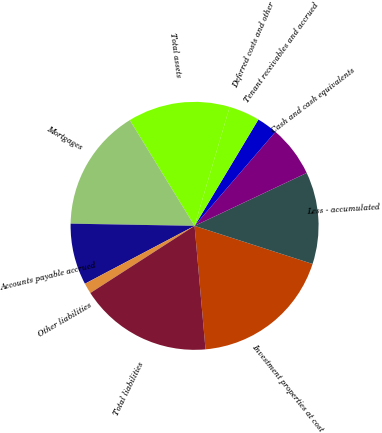<chart> <loc_0><loc_0><loc_500><loc_500><pie_chart><fcel>Investment properties at cost<fcel>Less - accumulated<fcel>Cash and cash equivalents<fcel>Tenant receivables and accrued<fcel>Deferred costs and other<fcel>Total assets<fcel>Mortgages<fcel>Accounts payable accrued<fcel>Other liabilities<fcel>Total liabilities<nl><fcel>18.62%<fcel>11.99%<fcel>6.68%<fcel>2.7%<fcel>4.03%<fcel>13.32%<fcel>15.97%<fcel>8.01%<fcel>1.38%<fcel>17.3%<nl></chart> 